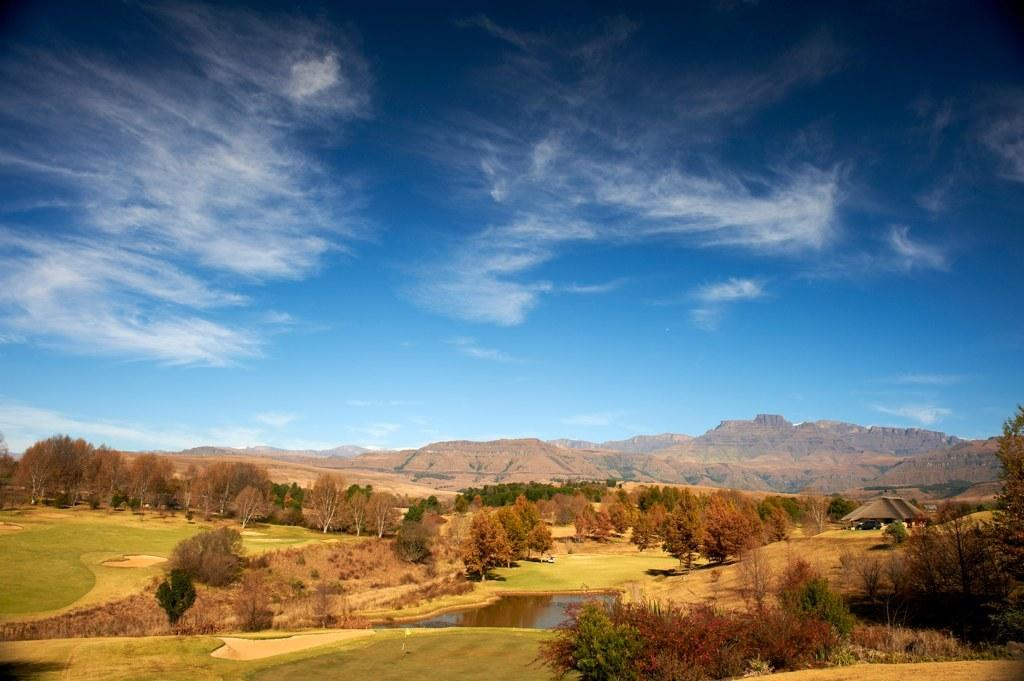What is the main subject in the center of the image? There is water in the center of the image. What type of vegetation can be seen in the image? There are trees visible in the image. What geographical features are present in the background of the image? There are hills in the background of the image. What is visible in the sky in the background of the image? The sky is visible in the background of the image. What shape are the bells in the image? There are no bells present in the image. How many points can be seen on the trees in the image? The trees in the image do not have points; they have branches and leaves. 